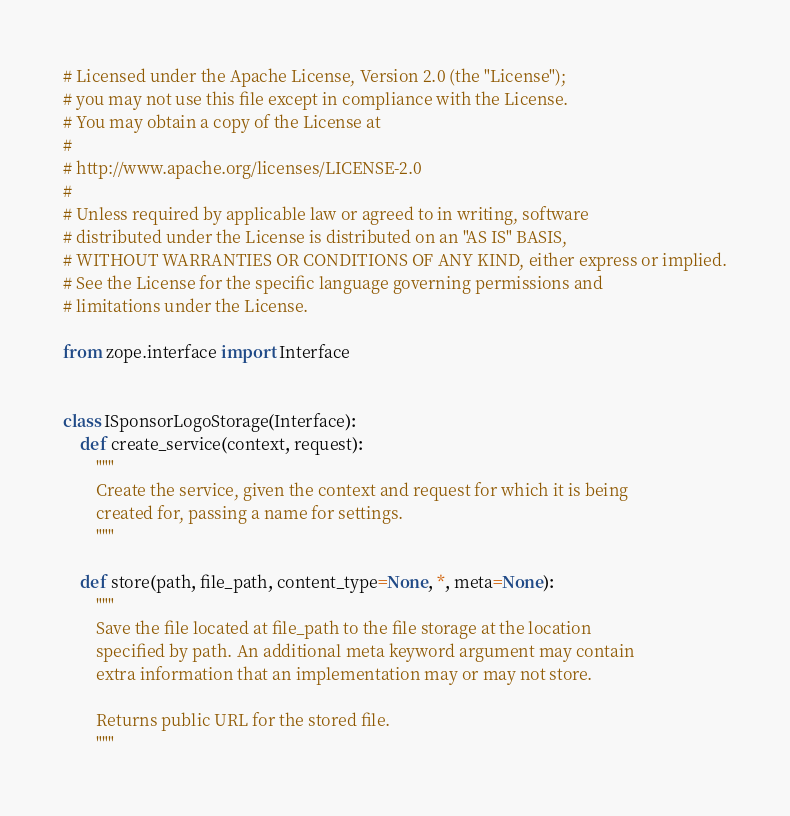<code> <loc_0><loc_0><loc_500><loc_500><_Python_># Licensed under the Apache License, Version 2.0 (the "License");
# you may not use this file except in compliance with the License.
# You may obtain a copy of the License at
#
# http://www.apache.org/licenses/LICENSE-2.0
#
# Unless required by applicable law or agreed to in writing, software
# distributed under the License is distributed on an "AS IS" BASIS,
# WITHOUT WARRANTIES OR CONDITIONS OF ANY KIND, either express or implied.
# See the License for the specific language governing permissions and
# limitations under the License.

from zope.interface import Interface


class ISponsorLogoStorage(Interface):
    def create_service(context, request):
        """
        Create the service, given the context and request for which it is being
        created for, passing a name for settings.
        """

    def store(path, file_path, content_type=None, *, meta=None):
        """
        Save the file located at file_path to the file storage at the location
        specified by path. An additional meta keyword argument may contain
        extra information that an implementation may or may not store.

        Returns public URL for the stored file.
        """
</code> 